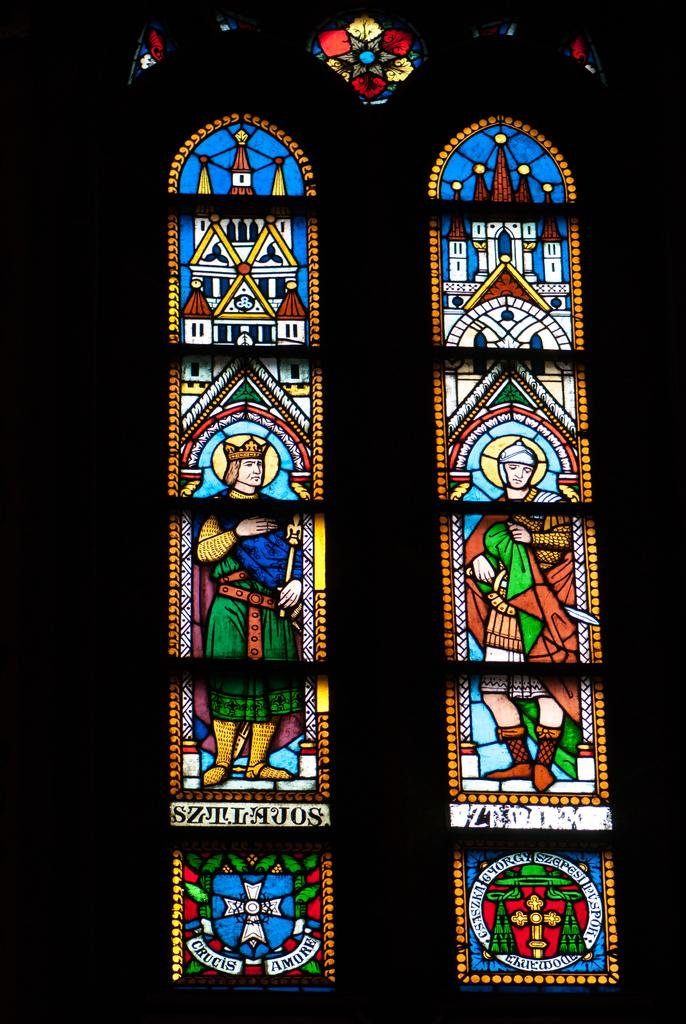What is the main subject of the image? The image contains a painting. What is being depicted in the painting? The painting depicts people and buildings. Are there any other elements in the painting besides people and buildings? Yes, the painting contains other things. How would you describe the lighting in the image? The image is slightly dark. What type of pen can be seen in the painting? There is no pen present in the painting; it depicts people, buildings, and other things. 